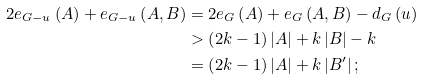Convert formula to latex. <formula><loc_0><loc_0><loc_500><loc_500>2 e _ { G - u } \left ( A \right ) + e _ { G - u } \left ( A , B \right ) & = 2 e _ { G } \left ( A \right ) + e _ { G } \left ( A , B \right ) - d _ { G } \left ( u \right ) \\ & > \left ( 2 k - 1 \right ) \left | A \right | + k \left | B \right | - k \\ & = \left ( 2 k - 1 \right ) \left | A \right | + k \left | B ^ { \prime } \right | ;</formula> 